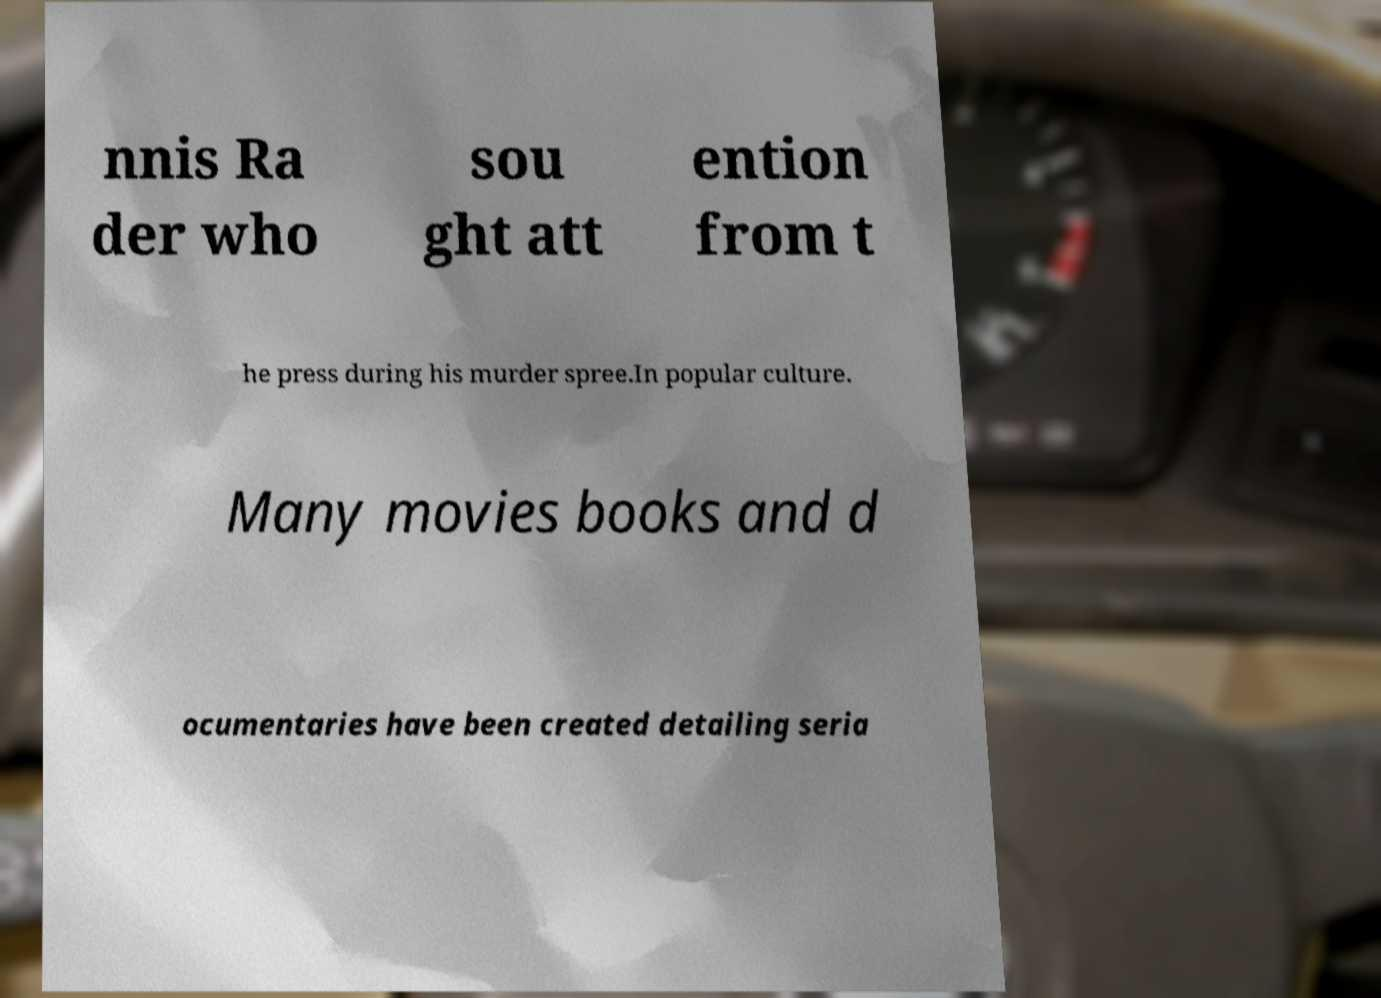Can you accurately transcribe the text from the provided image for me? nnis Ra der who sou ght att ention from t he press during his murder spree.In popular culture. Many movies books and d ocumentaries have been created detailing seria 